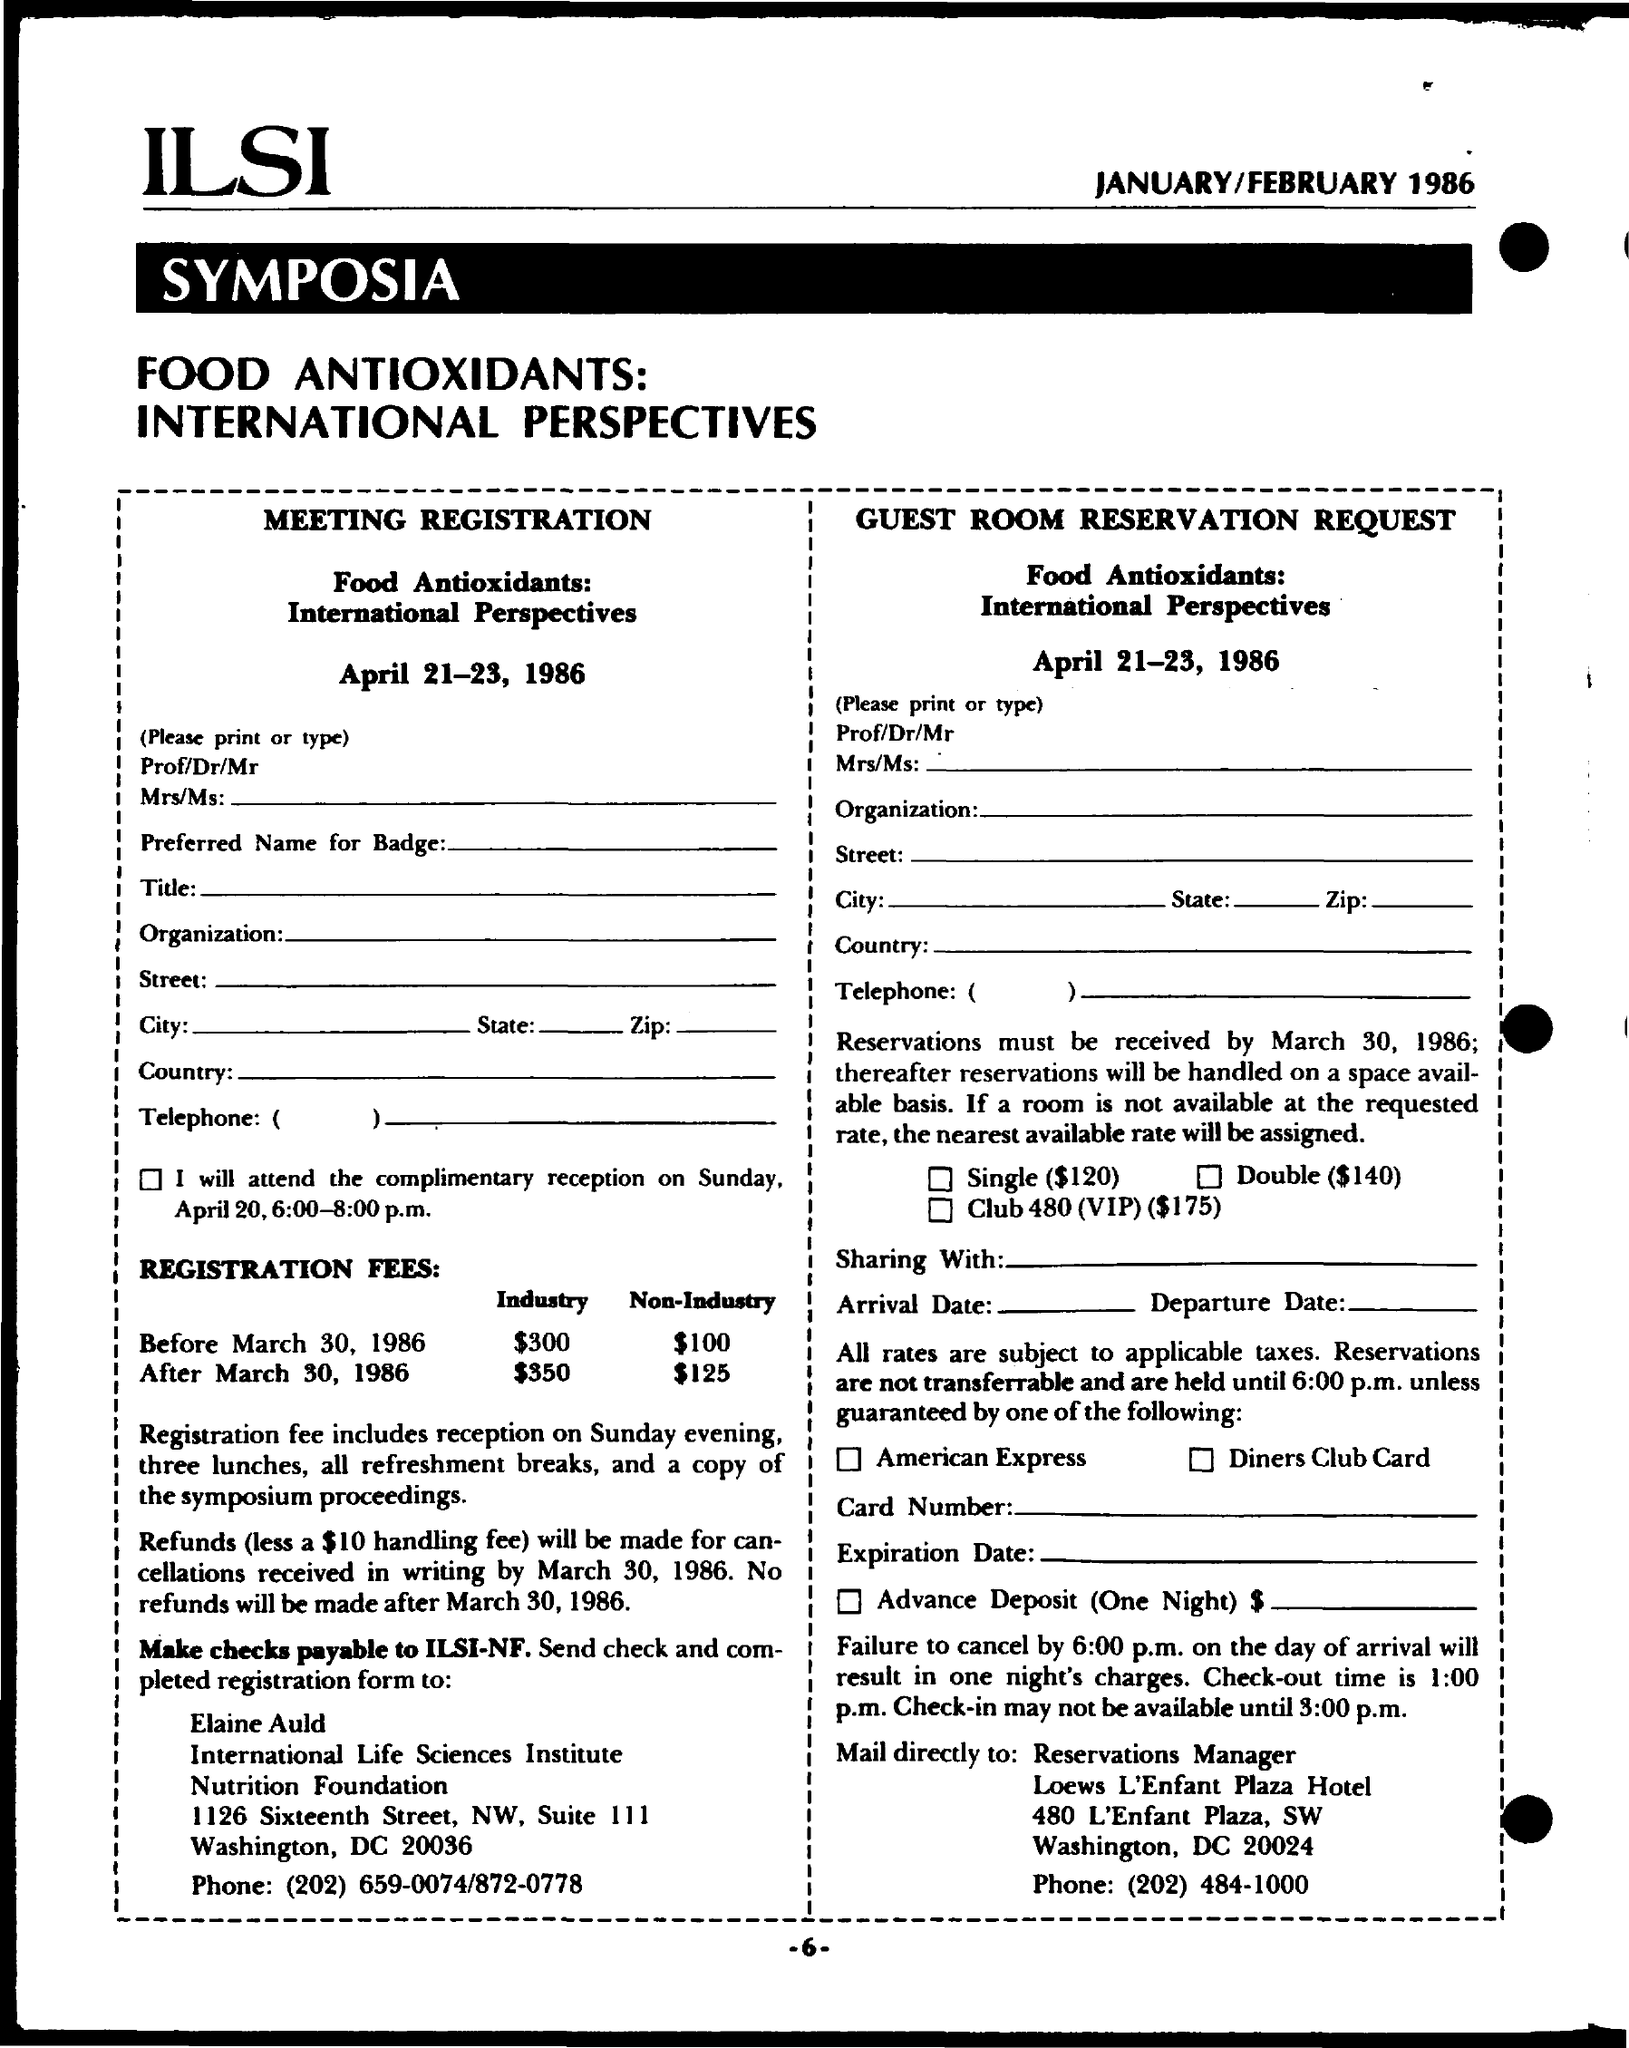Mention a couple of crucial points in this snapshot. The page number on this document is -6-. 